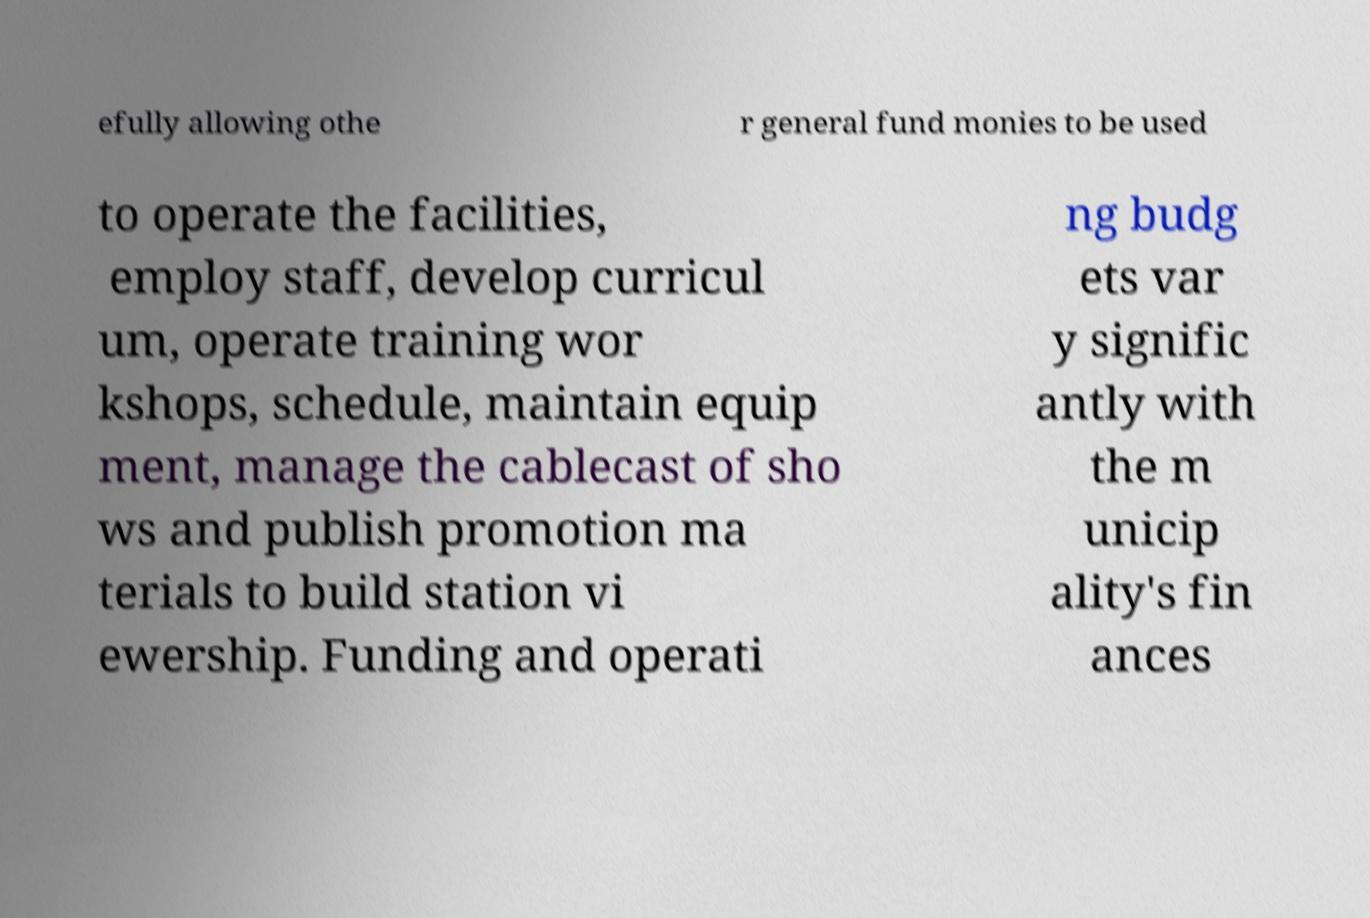Please read and relay the text visible in this image. What does it say? efully allowing othe r general fund monies to be used to operate the facilities, employ staff, develop curricul um, operate training wor kshops, schedule, maintain equip ment, manage the cablecast of sho ws and publish promotion ma terials to build station vi ewership. Funding and operati ng budg ets var y signific antly with the m unicip ality's fin ances 